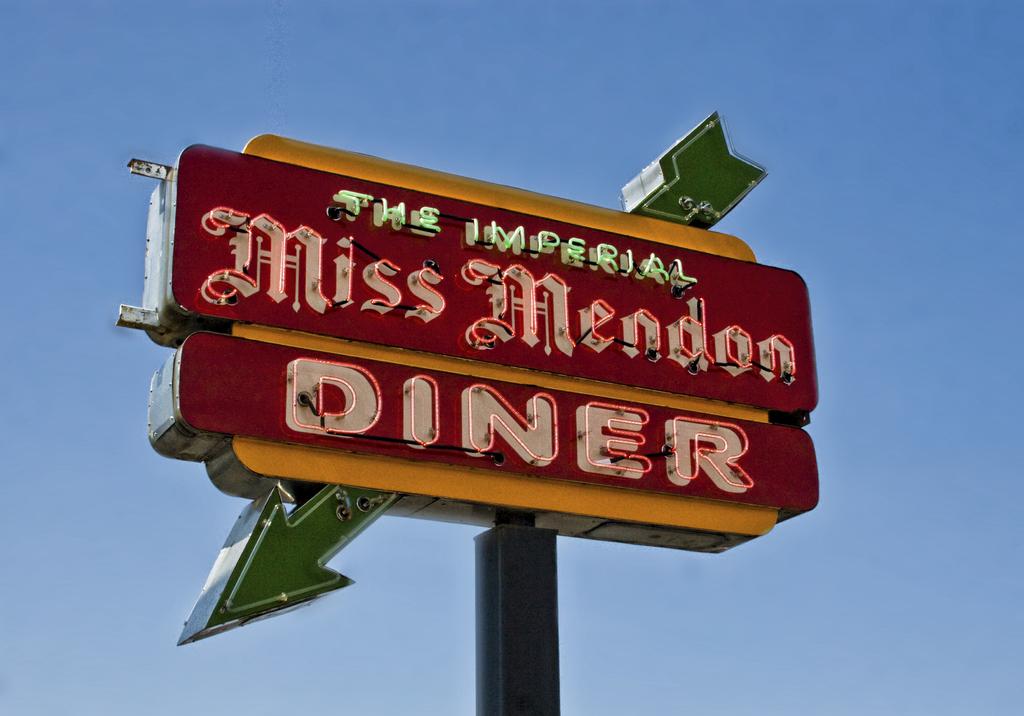What is the name of this place?
Your answer should be compact. Miss mendon diner. What are the words in green neon?
Provide a succinct answer. The imperial. 